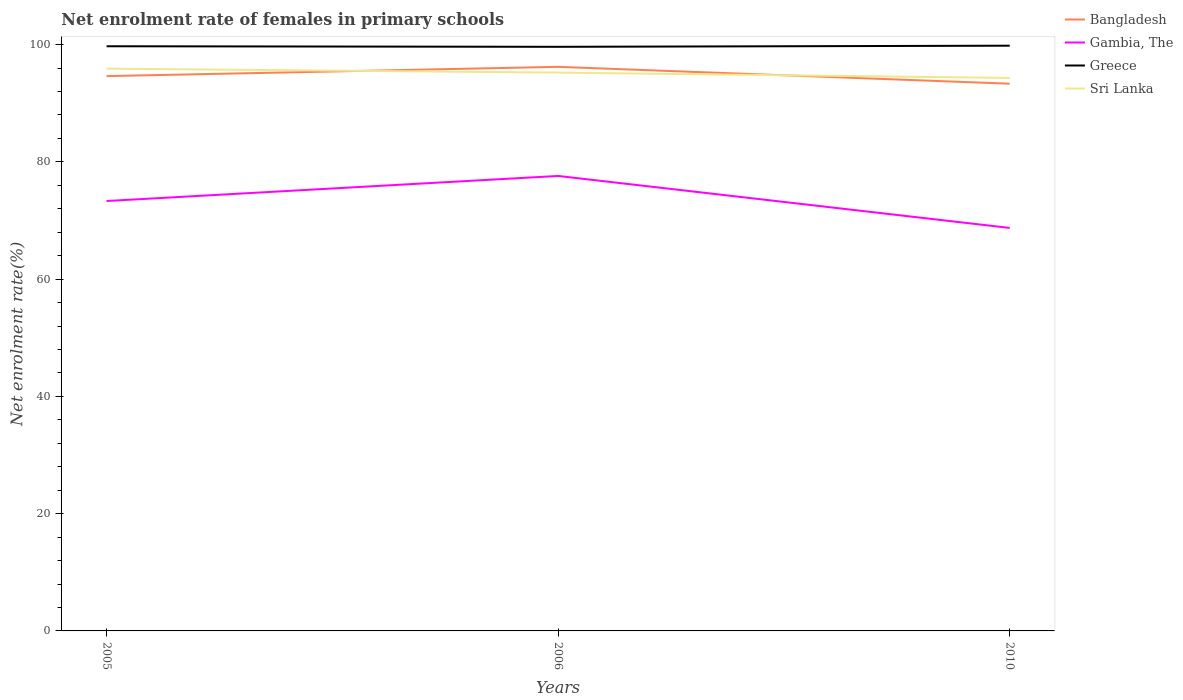Does the line corresponding to Gambia, The intersect with the line corresponding to Sri Lanka?
Offer a terse response. No. Is the number of lines equal to the number of legend labels?
Offer a very short reply. Yes. Across all years, what is the maximum net enrolment rate of females in primary schools in Greece?
Keep it short and to the point. 99.62. In which year was the net enrolment rate of females in primary schools in Bangladesh maximum?
Keep it short and to the point. 2010. What is the total net enrolment rate of females in primary schools in Gambia, The in the graph?
Offer a terse response. -4.27. What is the difference between the highest and the second highest net enrolment rate of females in primary schools in Greece?
Your answer should be very brief. 0.19. What is the difference between the highest and the lowest net enrolment rate of females in primary schools in Bangladesh?
Offer a very short reply. 1. Is the net enrolment rate of females in primary schools in Greece strictly greater than the net enrolment rate of females in primary schools in Gambia, The over the years?
Provide a succinct answer. No. How many lines are there?
Keep it short and to the point. 4. How many years are there in the graph?
Ensure brevity in your answer.  3. Are the values on the major ticks of Y-axis written in scientific E-notation?
Give a very brief answer. No. Does the graph contain grids?
Your answer should be very brief. No. Where does the legend appear in the graph?
Your answer should be very brief. Top right. How are the legend labels stacked?
Your answer should be compact. Vertical. What is the title of the graph?
Your answer should be very brief. Net enrolment rate of females in primary schools. Does "Armenia" appear as one of the legend labels in the graph?
Your response must be concise. No. What is the label or title of the X-axis?
Make the answer very short. Years. What is the label or title of the Y-axis?
Offer a very short reply. Net enrolment rate(%). What is the Net enrolment rate(%) of Bangladesh in 2005?
Your answer should be very brief. 94.62. What is the Net enrolment rate(%) of Gambia, The in 2005?
Your response must be concise. 73.32. What is the Net enrolment rate(%) in Greece in 2005?
Make the answer very short. 99.72. What is the Net enrolment rate(%) in Sri Lanka in 2005?
Offer a very short reply. 95.89. What is the Net enrolment rate(%) of Bangladesh in 2006?
Ensure brevity in your answer.  96.2. What is the Net enrolment rate(%) in Gambia, The in 2006?
Provide a short and direct response. 77.59. What is the Net enrolment rate(%) of Greece in 2006?
Your response must be concise. 99.62. What is the Net enrolment rate(%) of Sri Lanka in 2006?
Provide a succinct answer. 95.22. What is the Net enrolment rate(%) of Bangladesh in 2010?
Give a very brief answer. 93.33. What is the Net enrolment rate(%) in Gambia, The in 2010?
Ensure brevity in your answer.  68.73. What is the Net enrolment rate(%) of Greece in 2010?
Provide a short and direct response. 99.81. What is the Net enrolment rate(%) of Sri Lanka in 2010?
Offer a terse response. 94.31. Across all years, what is the maximum Net enrolment rate(%) in Bangladesh?
Provide a short and direct response. 96.2. Across all years, what is the maximum Net enrolment rate(%) in Gambia, The?
Offer a terse response. 77.59. Across all years, what is the maximum Net enrolment rate(%) in Greece?
Keep it short and to the point. 99.81. Across all years, what is the maximum Net enrolment rate(%) in Sri Lanka?
Your answer should be compact. 95.89. Across all years, what is the minimum Net enrolment rate(%) in Bangladesh?
Ensure brevity in your answer.  93.33. Across all years, what is the minimum Net enrolment rate(%) in Gambia, The?
Ensure brevity in your answer.  68.73. Across all years, what is the minimum Net enrolment rate(%) in Greece?
Offer a very short reply. 99.62. Across all years, what is the minimum Net enrolment rate(%) of Sri Lanka?
Give a very brief answer. 94.31. What is the total Net enrolment rate(%) in Bangladesh in the graph?
Offer a very short reply. 284.15. What is the total Net enrolment rate(%) of Gambia, The in the graph?
Make the answer very short. 219.64. What is the total Net enrolment rate(%) in Greece in the graph?
Your answer should be very brief. 299.14. What is the total Net enrolment rate(%) of Sri Lanka in the graph?
Your answer should be very brief. 285.42. What is the difference between the Net enrolment rate(%) in Bangladesh in 2005 and that in 2006?
Provide a short and direct response. -1.58. What is the difference between the Net enrolment rate(%) of Gambia, The in 2005 and that in 2006?
Offer a very short reply. -4.27. What is the difference between the Net enrolment rate(%) of Greece in 2005 and that in 2006?
Provide a succinct answer. 0.1. What is the difference between the Net enrolment rate(%) of Sri Lanka in 2005 and that in 2006?
Your response must be concise. 0.68. What is the difference between the Net enrolment rate(%) of Bangladesh in 2005 and that in 2010?
Your response must be concise. 1.3. What is the difference between the Net enrolment rate(%) in Gambia, The in 2005 and that in 2010?
Offer a terse response. 4.59. What is the difference between the Net enrolment rate(%) of Greece in 2005 and that in 2010?
Make the answer very short. -0.1. What is the difference between the Net enrolment rate(%) in Sri Lanka in 2005 and that in 2010?
Make the answer very short. 1.59. What is the difference between the Net enrolment rate(%) in Bangladesh in 2006 and that in 2010?
Your response must be concise. 2.88. What is the difference between the Net enrolment rate(%) in Gambia, The in 2006 and that in 2010?
Offer a terse response. 8.87. What is the difference between the Net enrolment rate(%) of Greece in 2006 and that in 2010?
Keep it short and to the point. -0.19. What is the difference between the Net enrolment rate(%) in Sri Lanka in 2006 and that in 2010?
Keep it short and to the point. 0.91. What is the difference between the Net enrolment rate(%) in Bangladesh in 2005 and the Net enrolment rate(%) in Gambia, The in 2006?
Make the answer very short. 17.03. What is the difference between the Net enrolment rate(%) of Bangladesh in 2005 and the Net enrolment rate(%) of Greece in 2006?
Your answer should be compact. -4.99. What is the difference between the Net enrolment rate(%) in Bangladesh in 2005 and the Net enrolment rate(%) in Sri Lanka in 2006?
Offer a terse response. -0.6. What is the difference between the Net enrolment rate(%) of Gambia, The in 2005 and the Net enrolment rate(%) of Greece in 2006?
Provide a short and direct response. -26.3. What is the difference between the Net enrolment rate(%) of Gambia, The in 2005 and the Net enrolment rate(%) of Sri Lanka in 2006?
Your response must be concise. -21.9. What is the difference between the Net enrolment rate(%) of Greece in 2005 and the Net enrolment rate(%) of Sri Lanka in 2006?
Your answer should be compact. 4.5. What is the difference between the Net enrolment rate(%) in Bangladesh in 2005 and the Net enrolment rate(%) in Gambia, The in 2010?
Your response must be concise. 25.89. What is the difference between the Net enrolment rate(%) of Bangladesh in 2005 and the Net enrolment rate(%) of Greece in 2010?
Provide a succinct answer. -5.19. What is the difference between the Net enrolment rate(%) of Bangladesh in 2005 and the Net enrolment rate(%) of Sri Lanka in 2010?
Offer a very short reply. 0.31. What is the difference between the Net enrolment rate(%) in Gambia, The in 2005 and the Net enrolment rate(%) in Greece in 2010?
Your answer should be very brief. -26.49. What is the difference between the Net enrolment rate(%) of Gambia, The in 2005 and the Net enrolment rate(%) of Sri Lanka in 2010?
Your response must be concise. -20.99. What is the difference between the Net enrolment rate(%) in Greece in 2005 and the Net enrolment rate(%) in Sri Lanka in 2010?
Offer a terse response. 5.41. What is the difference between the Net enrolment rate(%) of Bangladesh in 2006 and the Net enrolment rate(%) of Gambia, The in 2010?
Your answer should be very brief. 27.47. What is the difference between the Net enrolment rate(%) of Bangladesh in 2006 and the Net enrolment rate(%) of Greece in 2010?
Your answer should be compact. -3.61. What is the difference between the Net enrolment rate(%) of Bangladesh in 2006 and the Net enrolment rate(%) of Sri Lanka in 2010?
Offer a terse response. 1.89. What is the difference between the Net enrolment rate(%) in Gambia, The in 2006 and the Net enrolment rate(%) in Greece in 2010?
Your answer should be very brief. -22.22. What is the difference between the Net enrolment rate(%) in Gambia, The in 2006 and the Net enrolment rate(%) in Sri Lanka in 2010?
Offer a terse response. -16.72. What is the difference between the Net enrolment rate(%) of Greece in 2006 and the Net enrolment rate(%) of Sri Lanka in 2010?
Keep it short and to the point. 5.31. What is the average Net enrolment rate(%) of Bangladesh per year?
Provide a short and direct response. 94.72. What is the average Net enrolment rate(%) in Gambia, The per year?
Offer a very short reply. 73.21. What is the average Net enrolment rate(%) in Greece per year?
Provide a short and direct response. 99.71. What is the average Net enrolment rate(%) of Sri Lanka per year?
Make the answer very short. 95.14. In the year 2005, what is the difference between the Net enrolment rate(%) in Bangladesh and Net enrolment rate(%) in Gambia, The?
Your response must be concise. 21.3. In the year 2005, what is the difference between the Net enrolment rate(%) of Bangladesh and Net enrolment rate(%) of Greece?
Provide a succinct answer. -5.09. In the year 2005, what is the difference between the Net enrolment rate(%) of Bangladesh and Net enrolment rate(%) of Sri Lanka?
Provide a short and direct response. -1.27. In the year 2005, what is the difference between the Net enrolment rate(%) of Gambia, The and Net enrolment rate(%) of Greece?
Keep it short and to the point. -26.39. In the year 2005, what is the difference between the Net enrolment rate(%) in Gambia, The and Net enrolment rate(%) in Sri Lanka?
Give a very brief answer. -22.57. In the year 2005, what is the difference between the Net enrolment rate(%) in Greece and Net enrolment rate(%) in Sri Lanka?
Keep it short and to the point. 3.82. In the year 2006, what is the difference between the Net enrolment rate(%) in Bangladesh and Net enrolment rate(%) in Gambia, The?
Your answer should be very brief. 18.61. In the year 2006, what is the difference between the Net enrolment rate(%) of Bangladesh and Net enrolment rate(%) of Greece?
Ensure brevity in your answer.  -3.42. In the year 2006, what is the difference between the Net enrolment rate(%) of Bangladesh and Net enrolment rate(%) of Sri Lanka?
Your answer should be very brief. 0.98. In the year 2006, what is the difference between the Net enrolment rate(%) of Gambia, The and Net enrolment rate(%) of Greece?
Provide a succinct answer. -22.02. In the year 2006, what is the difference between the Net enrolment rate(%) in Gambia, The and Net enrolment rate(%) in Sri Lanka?
Provide a succinct answer. -17.63. In the year 2006, what is the difference between the Net enrolment rate(%) in Greece and Net enrolment rate(%) in Sri Lanka?
Your response must be concise. 4.4. In the year 2010, what is the difference between the Net enrolment rate(%) of Bangladesh and Net enrolment rate(%) of Gambia, The?
Your answer should be compact. 24.6. In the year 2010, what is the difference between the Net enrolment rate(%) of Bangladesh and Net enrolment rate(%) of Greece?
Offer a very short reply. -6.48. In the year 2010, what is the difference between the Net enrolment rate(%) of Bangladesh and Net enrolment rate(%) of Sri Lanka?
Provide a succinct answer. -0.98. In the year 2010, what is the difference between the Net enrolment rate(%) in Gambia, The and Net enrolment rate(%) in Greece?
Your response must be concise. -31.08. In the year 2010, what is the difference between the Net enrolment rate(%) in Gambia, The and Net enrolment rate(%) in Sri Lanka?
Provide a succinct answer. -25.58. In the year 2010, what is the difference between the Net enrolment rate(%) in Greece and Net enrolment rate(%) in Sri Lanka?
Ensure brevity in your answer.  5.5. What is the ratio of the Net enrolment rate(%) in Bangladesh in 2005 to that in 2006?
Your answer should be compact. 0.98. What is the ratio of the Net enrolment rate(%) in Gambia, The in 2005 to that in 2006?
Provide a succinct answer. 0.94. What is the ratio of the Net enrolment rate(%) of Greece in 2005 to that in 2006?
Your answer should be very brief. 1. What is the ratio of the Net enrolment rate(%) of Sri Lanka in 2005 to that in 2006?
Make the answer very short. 1.01. What is the ratio of the Net enrolment rate(%) in Bangladesh in 2005 to that in 2010?
Offer a terse response. 1.01. What is the ratio of the Net enrolment rate(%) in Gambia, The in 2005 to that in 2010?
Ensure brevity in your answer.  1.07. What is the ratio of the Net enrolment rate(%) in Greece in 2005 to that in 2010?
Offer a terse response. 1. What is the ratio of the Net enrolment rate(%) of Sri Lanka in 2005 to that in 2010?
Keep it short and to the point. 1.02. What is the ratio of the Net enrolment rate(%) of Bangladesh in 2006 to that in 2010?
Ensure brevity in your answer.  1.03. What is the ratio of the Net enrolment rate(%) of Gambia, The in 2006 to that in 2010?
Make the answer very short. 1.13. What is the ratio of the Net enrolment rate(%) in Greece in 2006 to that in 2010?
Your answer should be compact. 1. What is the ratio of the Net enrolment rate(%) in Sri Lanka in 2006 to that in 2010?
Your response must be concise. 1.01. What is the difference between the highest and the second highest Net enrolment rate(%) in Bangladesh?
Provide a succinct answer. 1.58. What is the difference between the highest and the second highest Net enrolment rate(%) of Gambia, The?
Your answer should be compact. 4.27. What is the difference between the highest and the second highest Net enrolment rate(%) of Greece?
Your answer should be compact. 0.1. What is the difference between the highest and the second highest Net enrolment rate(%) of Sri Lanka?
Provide a succinct answer. 0.68. What is the difference between the highest and the lowest Net enrolment rate(%) in Bangladesh?
Make the answer very short. 2.88. What is the difference between the highest and the lowest Net enrolment rate(%) in Gambia, The?
Ensure brevity in your answer.  8.87. What is the difference between the highest and the lowest Net enrolment rate(%) in Greece?
Ensure brevity in your answer.  0.19. What is the difference between the highest and the lowest Net enrolment rate(%) of Sri Lanka?
Offer a very short reply. 1.59. 